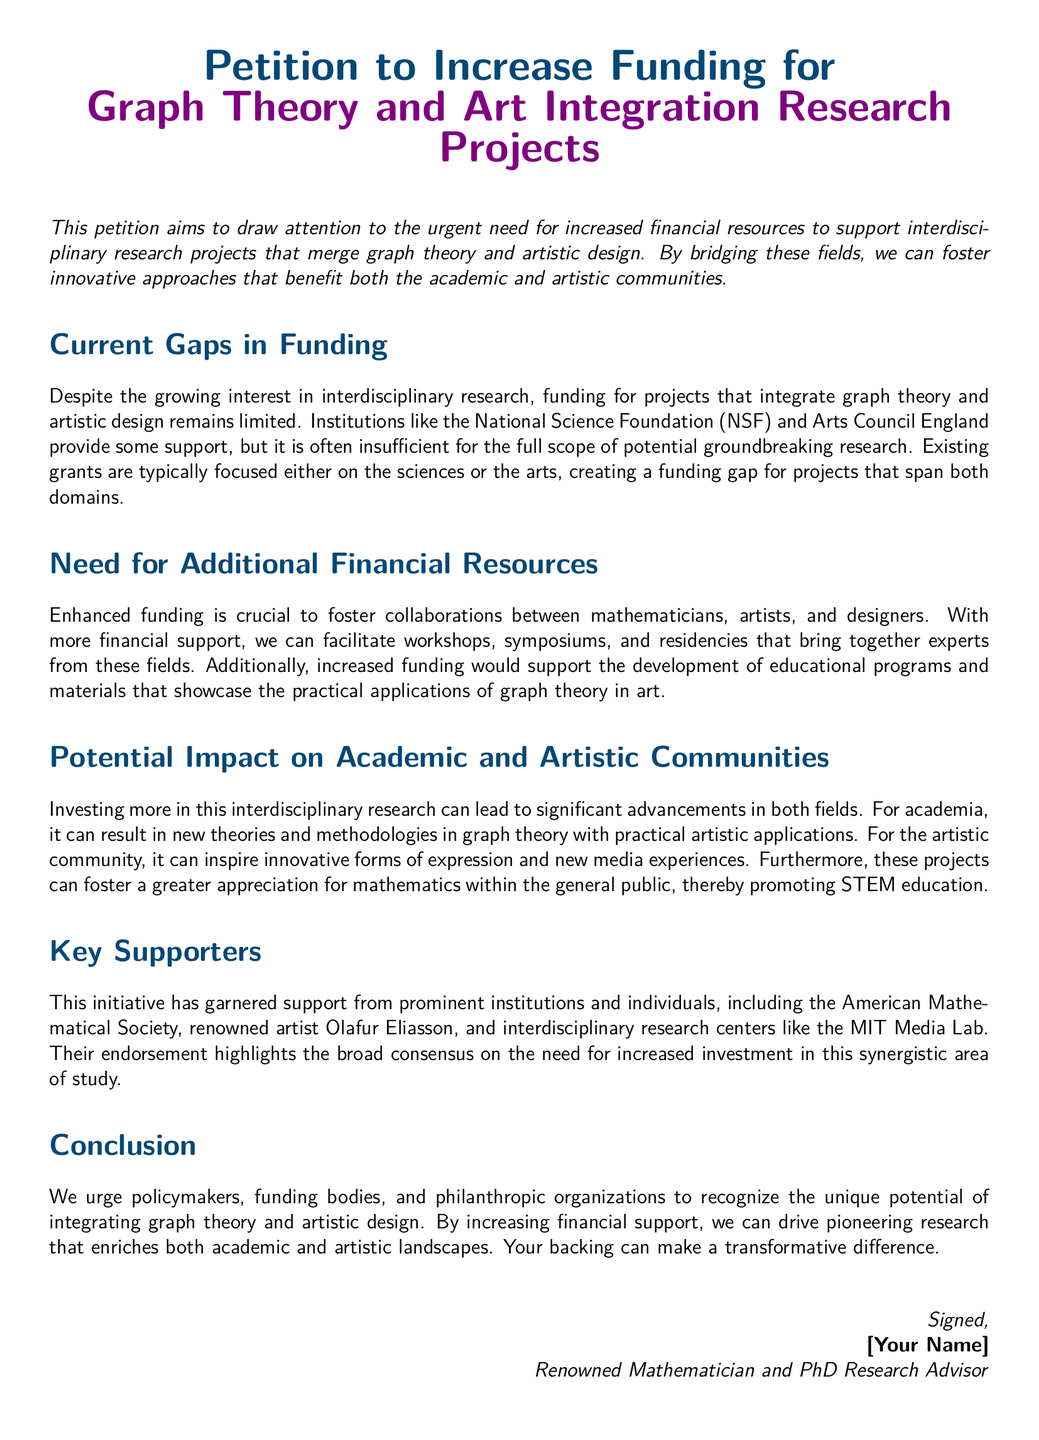What is the title of the petition? The title is found in the heading of the document, which outlines the main focus of the petition.
Answer: Petition to Increase Funding for Graph Theory and Art Integration Research Projects What is the main goal of this petition? The petition aims to draw attention to the need for increased financial resources to support interdisciplinary research projects.
Answer: Increased financial resources Which organizations are mentioned as providing support? The petition lists specific organizations involved in funding research, indicating the current landscape of support.
Answer: National Science Foundation and Arts Council England What significant event does the petition propose to facilitate? The document mentions specific events that would enhance collaboration between mathematicians and artists.
Answer: Workshops and symposiums Who is a prominent supporter mentioned in the petition? The document highlights individuals and groups that endorse the petition, showcasing its backing.
Answer: Olafur Eliasson What potential outcome is suggested for the academic community? The petition discusses possible benefits for academia as a result of the proposed funding increase.
Answer: New theories and methodologies What does the petition urge from policymakers? The final section of the document explicitly states the actions that the petition wants from influential figures.
Answer: Recognize the unique potential What color represents the academic section in the document? The color used for the text in the different sections can indicate thematic divisions in the document.
Answer: Math blue What is the document's primary audience? The aim and intent of the petition are directed towards a specific group of stakeholders.
Answer: Policymakers and funding bodies 